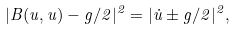Convert formula to latex. <formula><loc_0><loc_0><loc_500><loc_500>| B ( u , u ) - g / 2 | ^ { 2 } = | \dot { u } \pm g / 2 | ^ { 2 } ,</formula> 